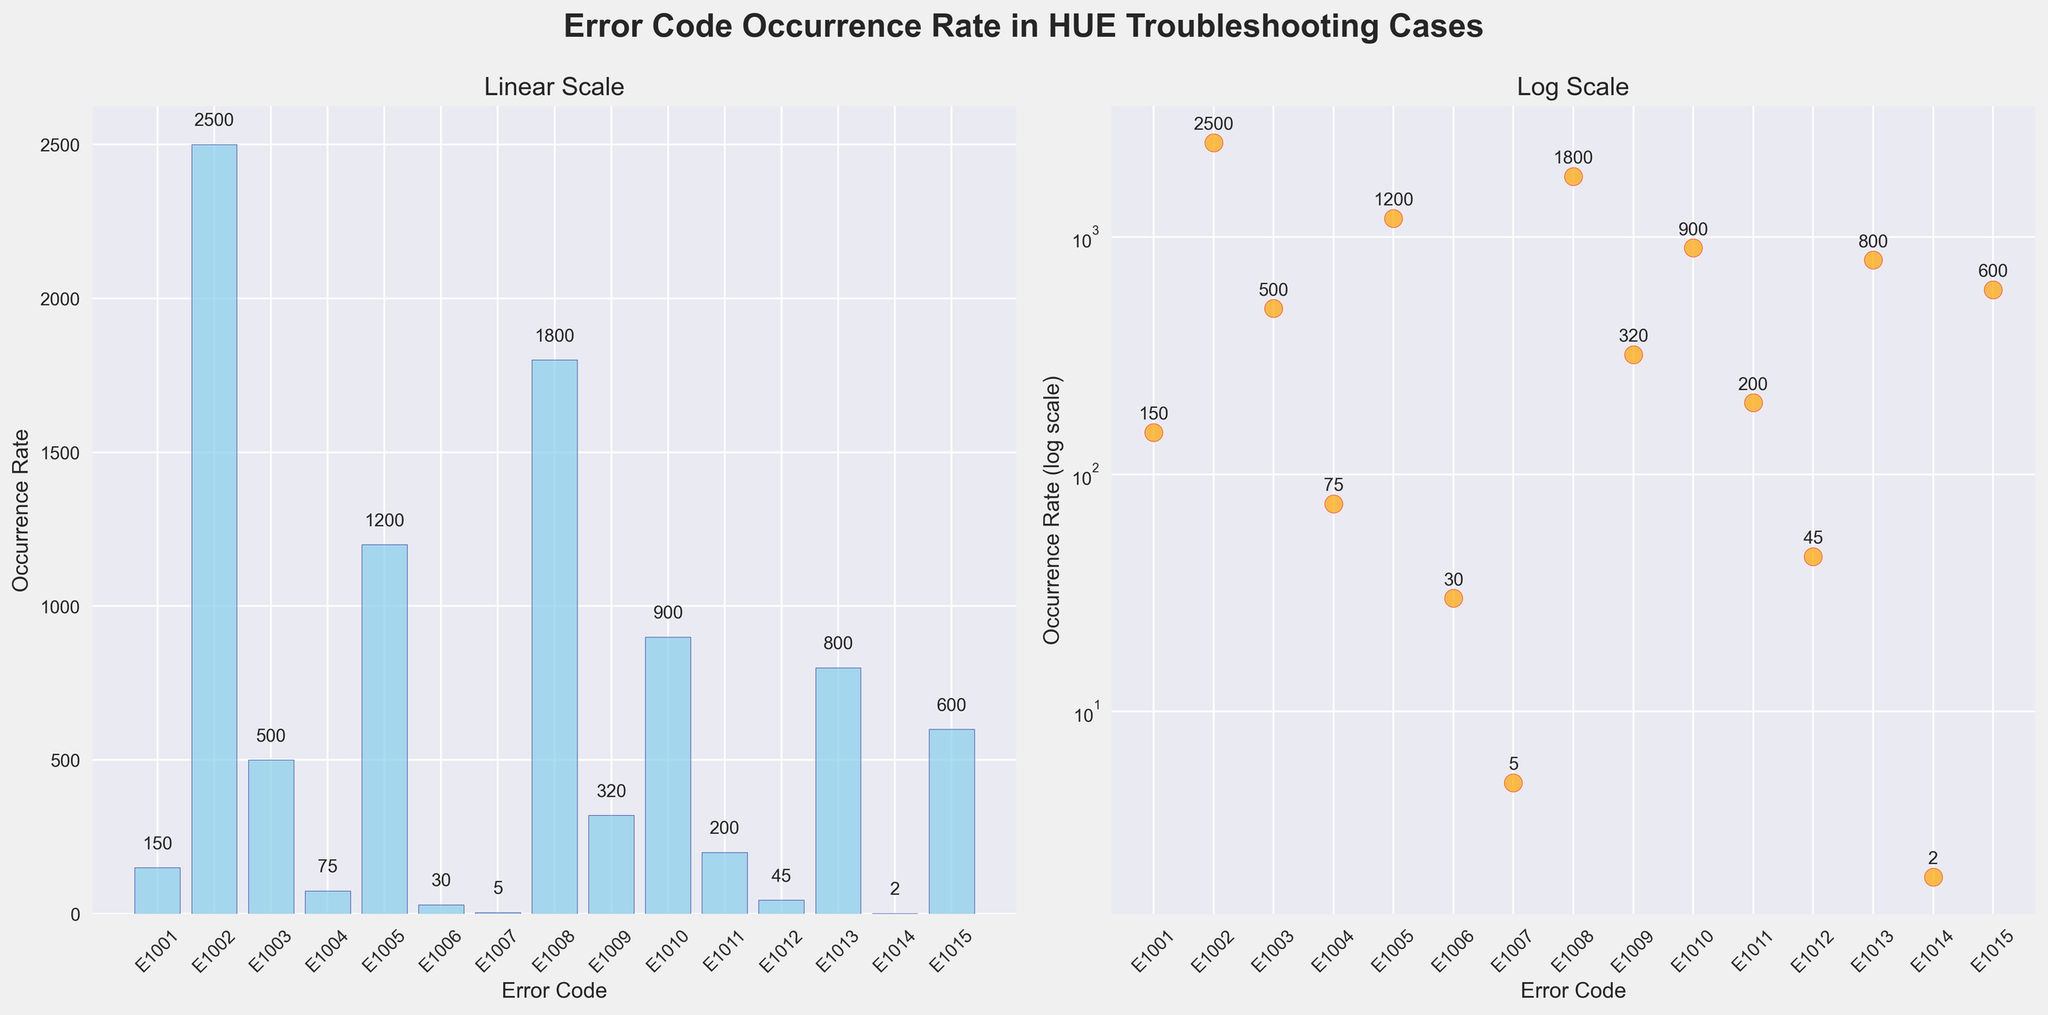What is the title of the figure? The title is located at the top center of the figure in bold large font. It states "Error Code Occurrence Rate in HUE Troubleshooting Cases".
Answer: Error Code Occurrence Rate in HUE Troubleshooting Cases How many error codes are represented in the figure? Count the number of distinct labels on the x-axis, which correspond to the error codes. There are 15 distinct error codes, from E1001 to E1015.
Answer: 15 Which error code has the highest occurrence rate? On the linear scale bar plot, look for the highest bar. Similarly, on the log scale scatter plot, look for the highest point. Both plots show that error code E1002 has the highest occurrence rate at 2500.
Answer: E1002 What is the occurrence rate of error code E1009? Locate error code E1009 on the x-axis and read its corresponding bar height on the linear scale plot or the position on the log scale plot. Both indicate an occurrence rate of 320.
Answer: 320 How does the occurrence rate of E1008 compare to that of E1013? On the log scale scatter plot, compare the positions of the points for E1008 and E1013. E1008 (1800) is higher than E1013 (800).
Answer: E1008 is higher On the log scale scatter plot, what happens to the occurrence rates visually for error codes with small values like E1014 and E1007? In the scatter plot with the log scale, error codes with very small occurrence rates such as E1014 and E1007 lie near the bottom, indicating their lower magnitude compared to others.
Answer: Near the bottom What is the average occurrence rate across all error codes? To find the average occurrence rate, sum all occurrence rates and divide by the number of error codes (15). The sum of occurrence rates is 817, which includes 150 + 2500 + 500 + 75 + 1200 + 30 + 5 + 1800 + 320 + 900 + 200 + 45 + 800 + 2 + 600, so the average is 8177 / 15 = 545.13.
Answer: 545.13 In which type of plot are the occurrence rates more distinguishable for lower values, linear scale or log scale? In the linear scale bar plot, lower values are compressed towards the bottom, making them harder to distinguish. In the log scale scatter plot, lower values are more spread out and clearly distinguishable.
Answer: Log scale Which error code has the lowest occurrence rate? On the linear scale bar plot, look for the smallest bar. Similarly, on the log scale scatter plot, locate the lowest point. Both show that error code E1014 has the lowest occurrence rate at 2.
Answer: E1014 What is the sum of the occurrence rates for error codes E1001, E1006, and E1011? The occurrence rates for E1001, E1006, and E1011 are 150, 30, and 200 respectively. Summing these values gives 150 + 30 + 200 = 380.
Answer: 380 